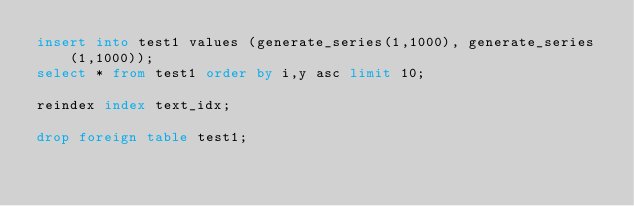<code> <loc_0><loc_0><loc_500><loc_500><_SQL_>insert into test1 values (generate_series(1,1000), generate_series(1,1000));
select * from test1 order by i,y asc limit 10;

reindex index text_idx;

drop foreign table test1;
</code> 